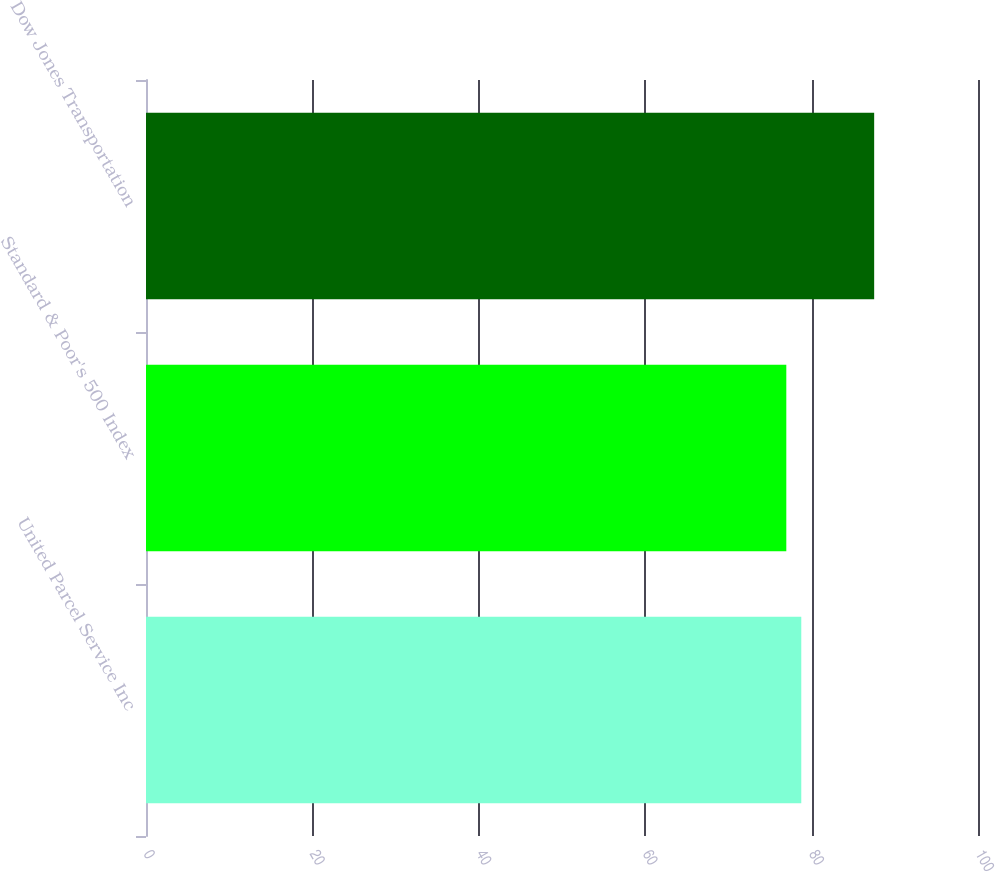Convert chart to OTSL. <chart><loc_0><loc_0><loc_500><loc_500><bar_chart><fcel>United Parcel Service Inc<fcel>Standard & Poor's 500 Index<fcel>Dow Jones Transportation<nl><fcel>78.76<fcel>76.96<fcel>87.52<nl></chart> 